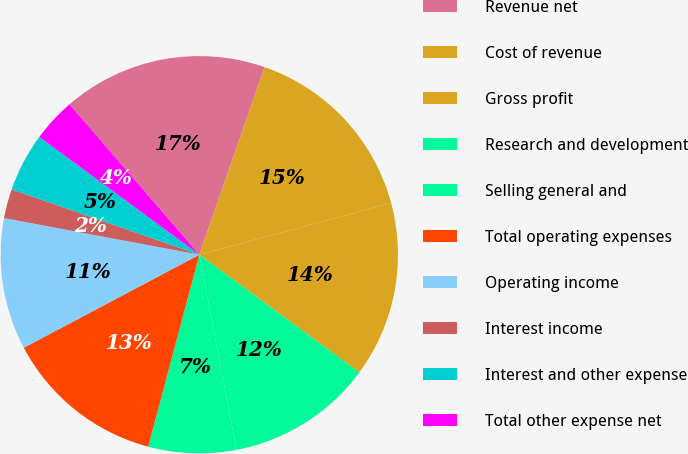<chart> <loc_0><loc_0><loc_500><loc_500><pie_chart><fcel>Revenue net<fcel>Cost of revenue<fcel>Gross profit<fcel>Research and development<fcel>Selling general and<fcel>Total operating expenses<fcel>Operating income<fcel>Interest income<fcel>Interest and other expense<fcel>Total other expense net<nl><fcel>16.66%<fcel>15.47%<fcel>14.28%<fcel>11.9%<fcel>7.14%<fcel>13.09%<fcel>10.71%<fcel>2.38%<fcel>4.76%<fcel>3.57%<nl></chart> 